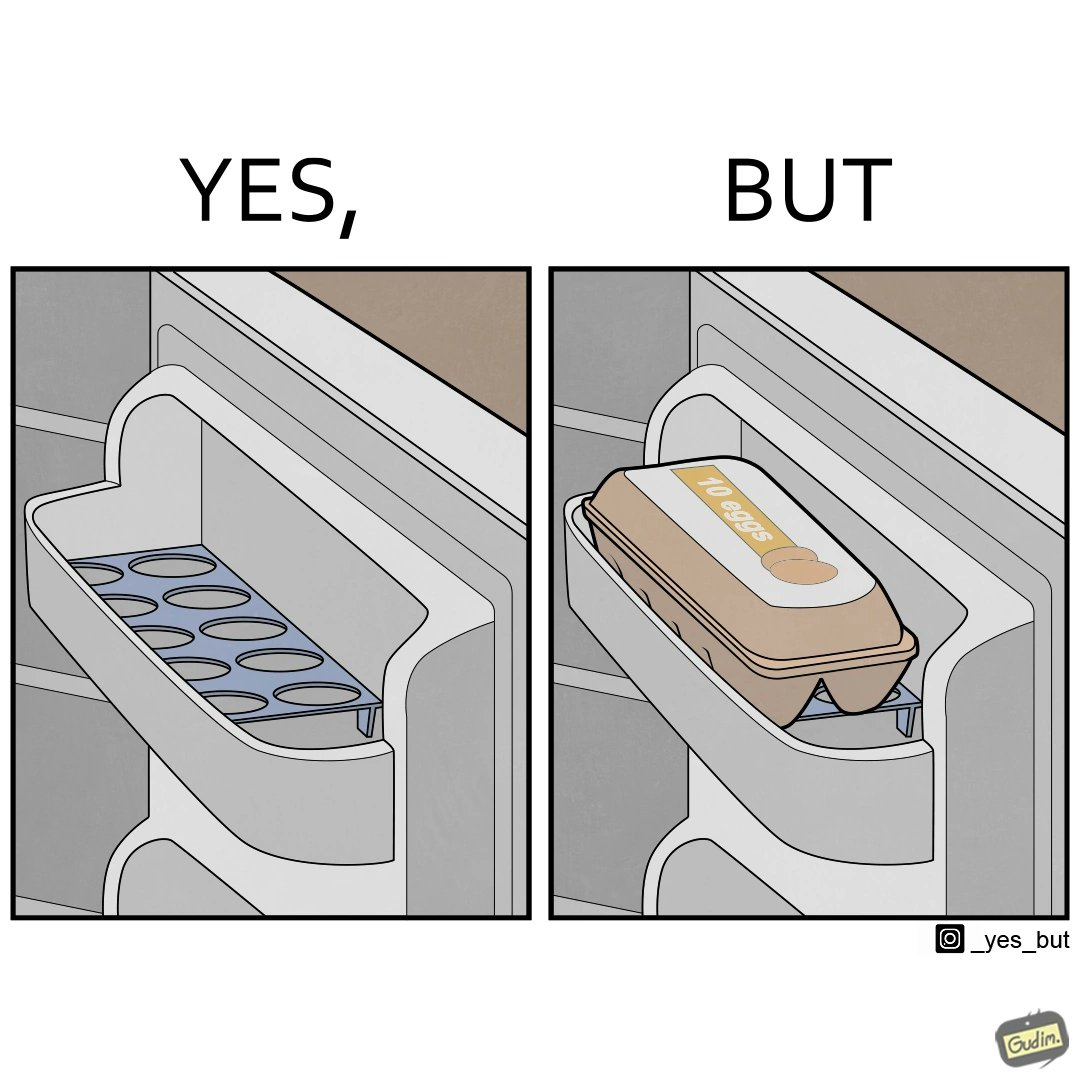What do you see in each half of this image? In the left part of the image: It is an egg tray in a  refrigerator In the right part of the image: It is a box of eggs in a refrigerator 